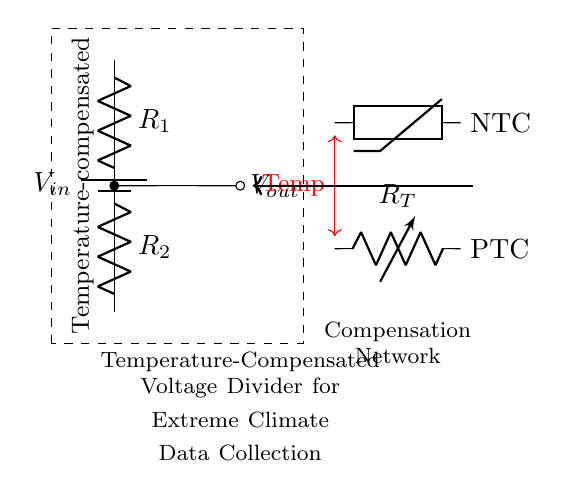What is the input voltage represented in the circuit? The input voltage is represented by the source labeled $V_{in}$ at the top of the diagram, indicating the voltage supplied to the circuit.
Answer: Vin What type of resistors are used in the circuit? The circuit diagram shows two resistors labeled $R_1$ and $R_2$, indicating that these are passive components.
Answer: Resistors What are the components used for temperature compensation? The circuit includes an NTC thermistor and a PTC resistor labeled $R_T$, indicating that these components are used to compensate for temperature variations.
Answer: NTC thermistor and PTC resistor How many resistive elements are in the voltage divider? There are two resistive elements: $R_1$ and $R_2$, which are part of the voltage divider configuration.
Answer: Two Explain how temperature compensation is achieved in this circuit. The circuit employs both an NTC thermistor and a PTC resistor to create a balance in resistance change due to temperature fluctuations, effectively stabilizing the output voltage under varying thermal conditions.
Answer: NTC and PTC resistors stabilize output What is the purpose of the dashed rectangle drawn around the circuit? The dashed rectangle highlights the area of the voltage divider circuit and indicates the section that focuses on the temperature compensation network necessary for accurate data collection in extreme climates.
Answer: Highlight voltage divider section 